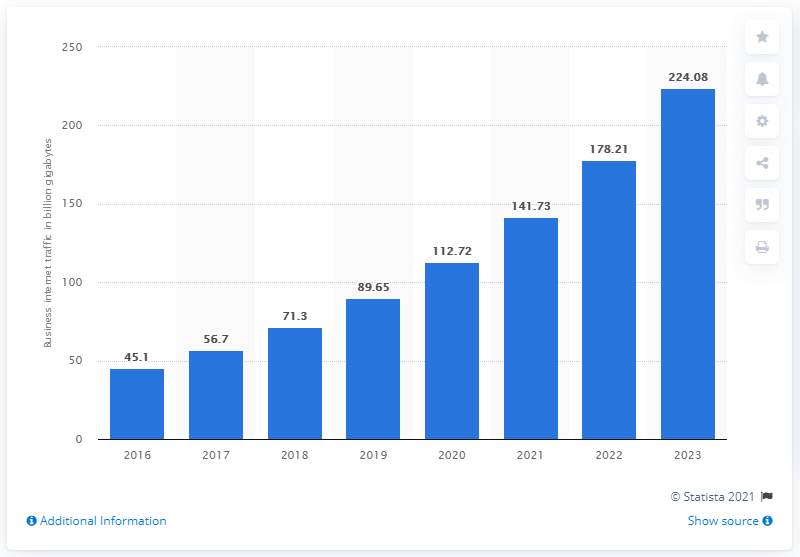Identify some key points in this picture. In the year 2017, the total volume of business internet traffic in the United States was 56.7. 